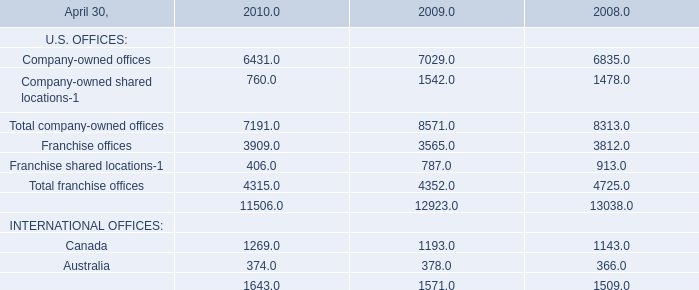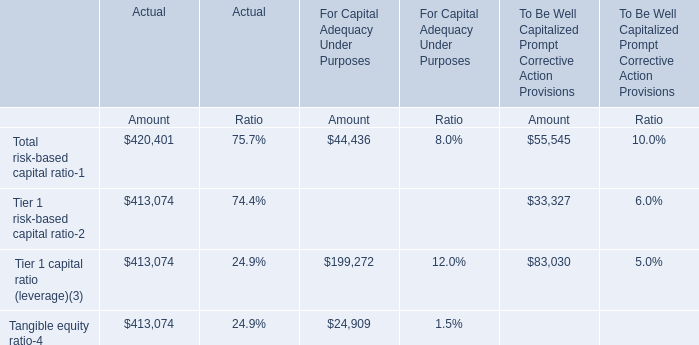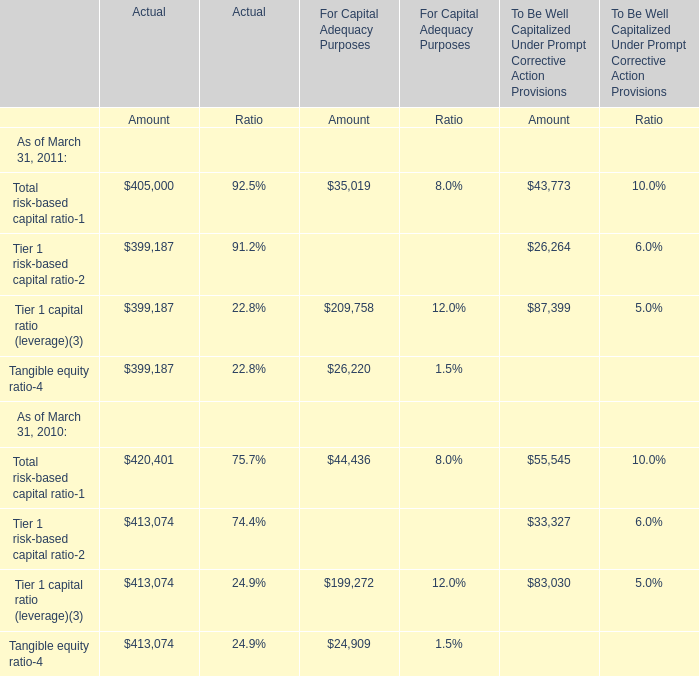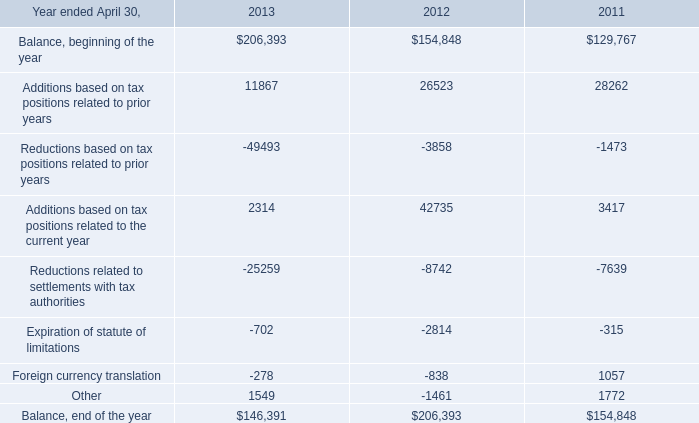What is the average amount of Franchise offices of 2008, and Tangible equity ratio of Actual Amount ? 
Computations: ((3812.0 + 413074.0) / 2)
Answer: 208443.0. 